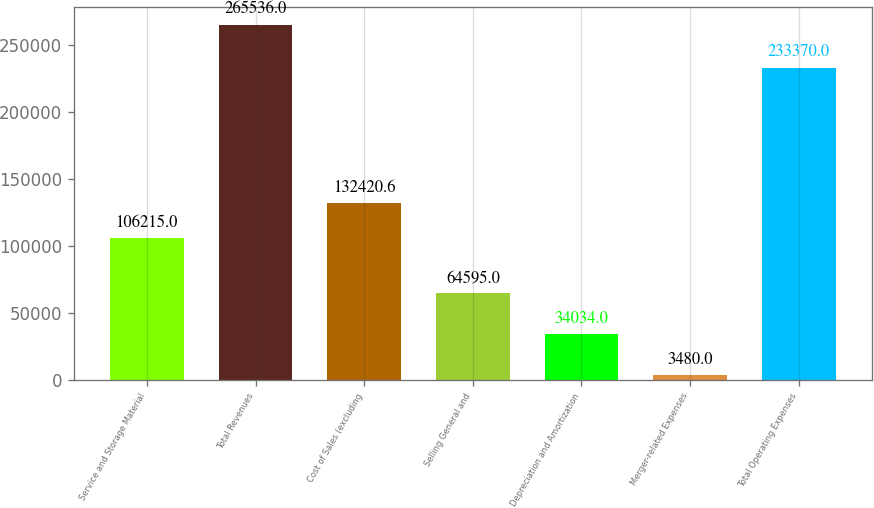Convert chart. <chart><loc_0><loc_0><loc_500><loc_500><bar_chart><fcel>Service and Storage Material<fcel>Total Revenues<fcel>Cost of Sales (excluding<fcel>Selling General and<fcel>Depreciation and Amortization<fcel>Merger-related Expenses<fcel>Total Operating Expenses<nl><fcel>106215<fcel>265536<fcel>132421<fcel>64595<fcel>34034<fcel>3480<fcel>233370<nl></chart> 